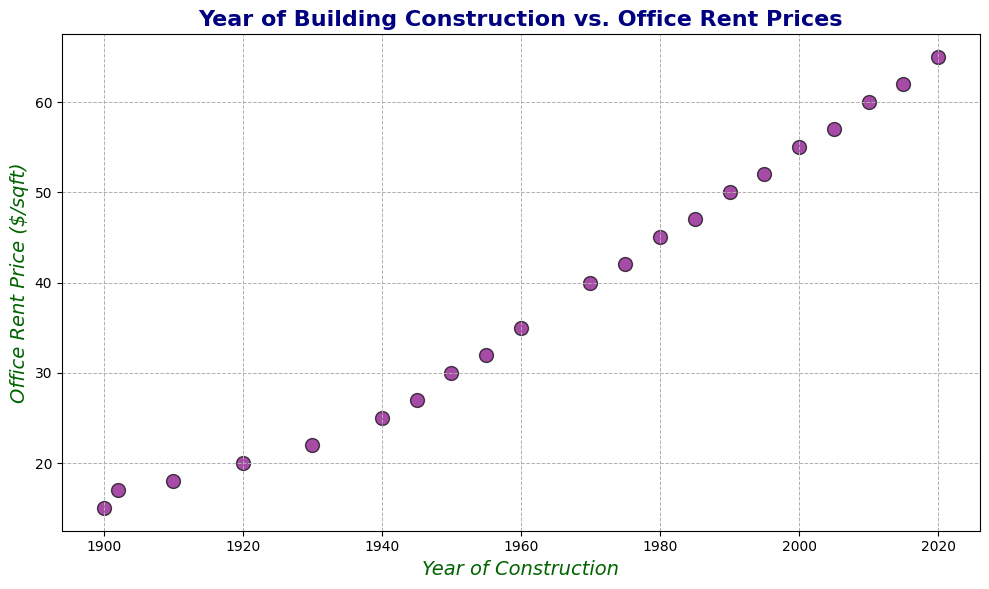What is the trend in office rent prices from 1900 to 2020? By observing the scatter plot, we see an upward trend in office rent prices from 1900 to 2020. Each newer construction year generally shows a higher rent price on the scatter plot.
Answer: Upward trend Which year has the highest office rent price? The highest point on the y-axis represents the highest office rent price. From the scatter plot, the year 2020 has the highest office rent price of $65 per sqft.
Answer: 2020 Compare office rent prices in 1940 and 1980. Which year has higher prices? By comparing the scatter points for 1940 and 1980 on the plot, we see that 1980 has a higher rent price ($45 per sqft) compared to 1940 ($25 per sqft).
Answer: 1980 What is the average office rent price for buildings constructed between 1900 and 1930? The years within the range are 1900 ($15), 1910 ($18), 1920 ($20), and 1930 ($22). Adding these values gives: 15 + 18 + 20 + 22 = 75. Dividing by the number of values (4) gives 75/4 = 18.75.
Answer: $18.75 per sqft What is the difference in rent prices between buildings constructed in 1950 and 1980? Rent prices for 1950 and 1980 are $30 and $45 per sqft, respectively. The difference is 45 - 30 = $15 per sqft.
Answer: $15 per sqft How many buildings constructed in the 1900s have rent prices below $30 per sqft? From the scatter plot, the buildings constructed in 1900s and their respective rent prices below $30 per sqft are 1900 ($15), 1910 ($18), 1920 ($20), 1930 ($22), and 1945 ($27). There are 5 such buildings.
Answer: 5 buildings What color represents the scatter points on the plot? Observing the scatter plot, the points are colored purple with black edges.
Answer: Purple Which decade shows the largest increase in office rent prices compared to its previous decade? Observing the scatter plot's y-axis, the largest increase happens from 1950 ($30) to 1960 ($35), an increase of $5 per sqft. Other decade differences are smaller.
Answer: 1950 to 1960 